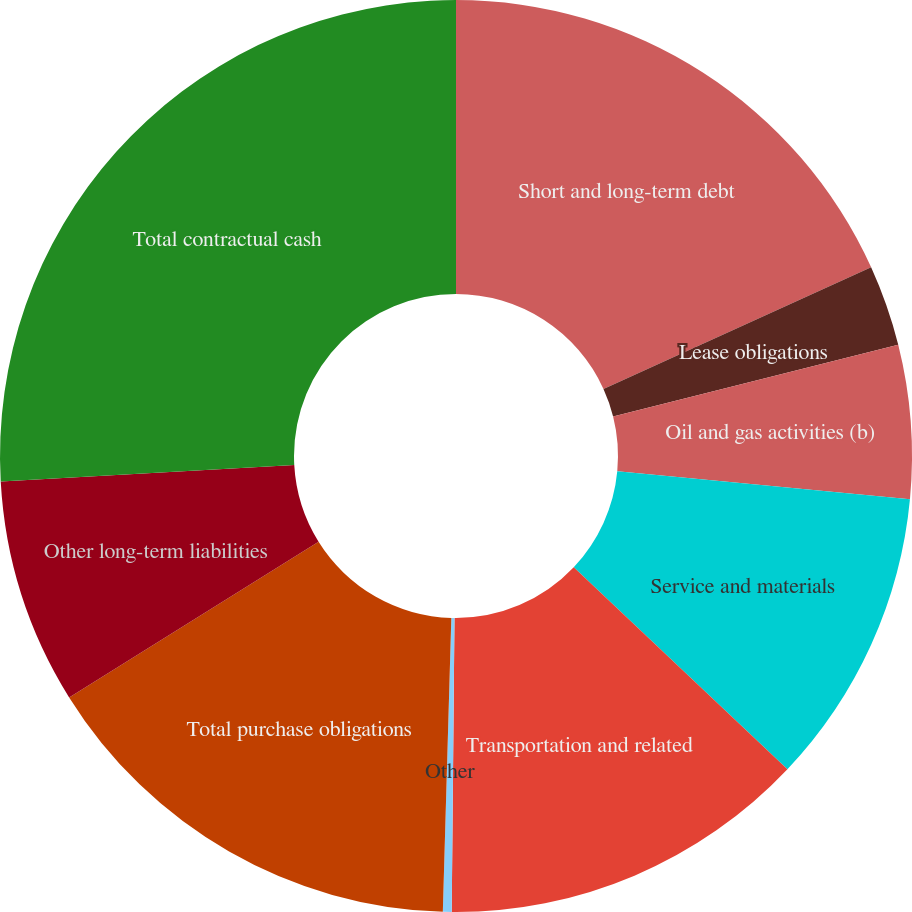Convert chart. <chart><loc_0><loc_0><loc_500><loc_500><pie_chart><fcel>Short and long-term debt<fcel>Lease obligations<fcel>Oil and gas activities (b)<fcel>Service and materials<fcel>Transportation and related<fcel>Other<fcel>Total purchase obligations<fcel>Other long-term liabilities<fcel>Total contractual cash<nl><fcel>18.21%<fcel>2.87%<fcel>5.43%<fcel>10.54%<fcel>13.1%<fcel>0.31%<fcel>15.66%<fcel>7.99%<fcel>25.89%<nl></chart> 